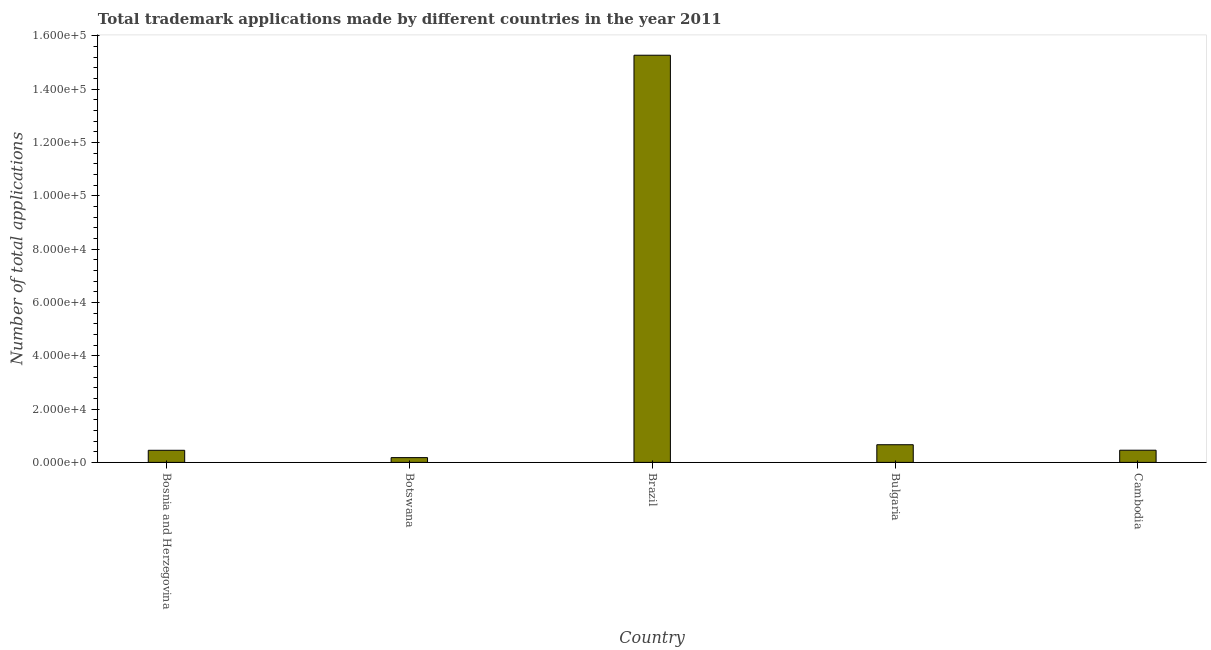Does the graph contain any zero values?
Offer a terse response. No. Does the graph contain grids?
Make the answer very short. No. What is the title of the graph?
Provide a short and direct response. Total trademark applications made by different countries in the year 2011. What is the label or title of the Y-axis?
Ensure brevity in your answer.  Number of total applications. What is the number of trademark applications in Brazil?
Provide a succinct answer. 1.53e+05. Across all countries, what is the maximum number of trademark applications?
Keep it short and to the point. 1.53e+05. Across all countries, what is the minimum number of trademark applications?
Ensure brevity in your answer.  1793. In which country was the number of trademark applications minimum?
Your answer should be compact. Botswana. What is the sum of the number of trademark applications?
Provide a short and direct response. 1.70e+05. What is the difference between the number of trademark applications in Botswana and Brazil?
Provide a succinct answer. -1.51e+05. What is the average number of trademark applications per country?
Make the answer very short. 3.40e+04. What is the median number of trademark applications?
Provide a succinct answer. 4567. In how many countries, is the number of trademark applications greater than 52000 ?
Offer a very short reply. 1. What is the ratio of the number of trademark applications in Bosnia and Herzegovina to that in Botswana?
Your answer should be very brief. 2.53. Is the number of trademark applications in Bosnia and Herzegovina less than that in Botswana?
Ensure brevity in your answer.  No. What is the difference between the highest and the second highest number of trademark applications?
Ensure brevity in your answer.  1.46e+05. Is the sum of the number of trademark applications in Bulgaria and Cambodia greater than the maximum number of trademark applications across all countries?
Give a very brief answer. No. What is the difference between the highest and the lowest number of trademark applications?
Offer a terse response. 1.51e+05. How many bars are there?
Provide a short and direct response. 5. How many countries are there in the graph?
Make the answer very short. 5. What is the Number of total applications in Bosnia and Herzegovina?
Offer a very short reply. 4538. What is the Number of total applications in Botswana?
Provide a short and direct response. 1793. What is the Number of total applications of Brazil?
Your response must be concise. 1.53e+05. What is the Number of total applications in Bulgaria?
Your response must be concise. 6626. What is the Number of total applications in Cambodia?
Provide a succinct answer. 4567. What is the difference between the Number of total applications in Bosnia and Herzegovina and Botswana?
Give a very brief answer. 2745. What is the difference between the Number of total applications in Bosnia and Herzegovina and Brazil?
Provide a short and direct response. -1.48e+05. What is the difference between the Number of total applications in Bosnia and Herzegovina and Bulgaria?
Provide a short and direct response. -2088. What is the difference between the Number of total applications in Botswana and Brazil?
Keep it short and to the point. -1.51e+05. What is the difference between the Number of total applications in Botswana and Bulgaria?
Your response must be concise. -4833. What is the difference between the Number of total applications in Botswana and Cambodia?
Your answer should be very brief. -2774. What is the difference between the Number of total applications in Brazil and Bulgaria?
Offer a terse response. 1.46e+05. What is the difference between the Number of total applications in Brazil and Cambodia?
Ensure brevity in your answer.  1.48e+05. What is the difference between the Number of total applications in Bulgaria and Cambodia?
Your answer should be compact. 2059. What is the ratio of the Number of total applications in Bosnia and Herzegovina to that in Botswana?
Your answer should be compact. 2.53. What is the ratio of the Number of total applications in Bosnia and Herzegovina to that in Bulgaria?
Your answer should be very brief. 0.69. What is the ratio of the Number of total applications in Bosnia and Herzegovina to that in Cambodia?
Your answer should be compact. 0.99. What is the ratio of the Number of total applications in Botswana to that in Brazil?
Your answer should be compact. 0.01. What is the ratio of the Number of total applications in Botswana to that in Bulgaria?
Keep it short and to the point. 0.27. What is the ratio of the Number of total applications in Botswana to that in Cambodia?
Give a very brief answer. 0.39. What is the ratio of the Number of total applications in Brazil to that in Bulgaria?
Make the answer very short. 23.05. What is the ratio of the Number of total applications in Brazil to that in Cambodia?
Your answer should be compact. 33.44. What is the ratio of the Number of total applications in Bulgaria to that in Cambodia?
Your answer should be very brief. 1.45. 